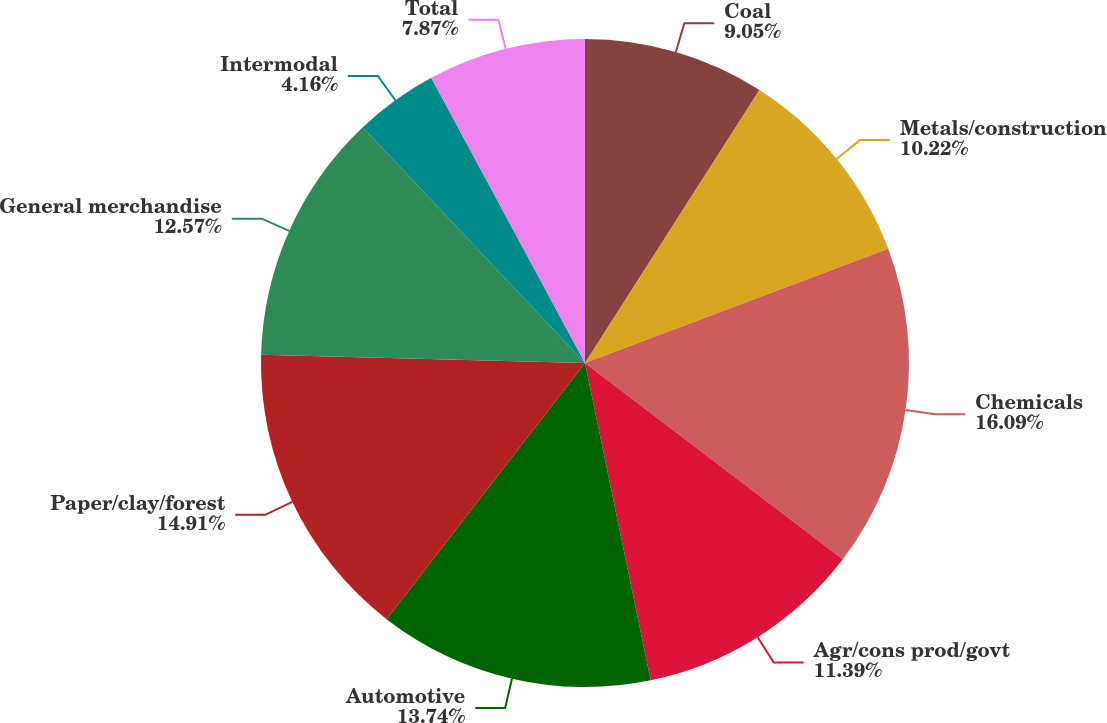Convert chart. <chart><loc_0><loc_0><loc_500><loc_500><pie_chart><fcel>Coal<fcel>Metals/construction<fcel>Chemicals<fcel>Agr/cons prod/govt<fcel>Automotive<fcel>Paper/clay/forest<fcel>General merchandise<fcel>Intermodal<fcel>Total<nl><fcel>9.05%<fcel>10.22%<fcel>16.09%<fcel>11.39%<fcel>13.74%<fcel>14.91%<fcel>12.57%<fcel>4.16%<fcel>7.87%<nl></chart> 